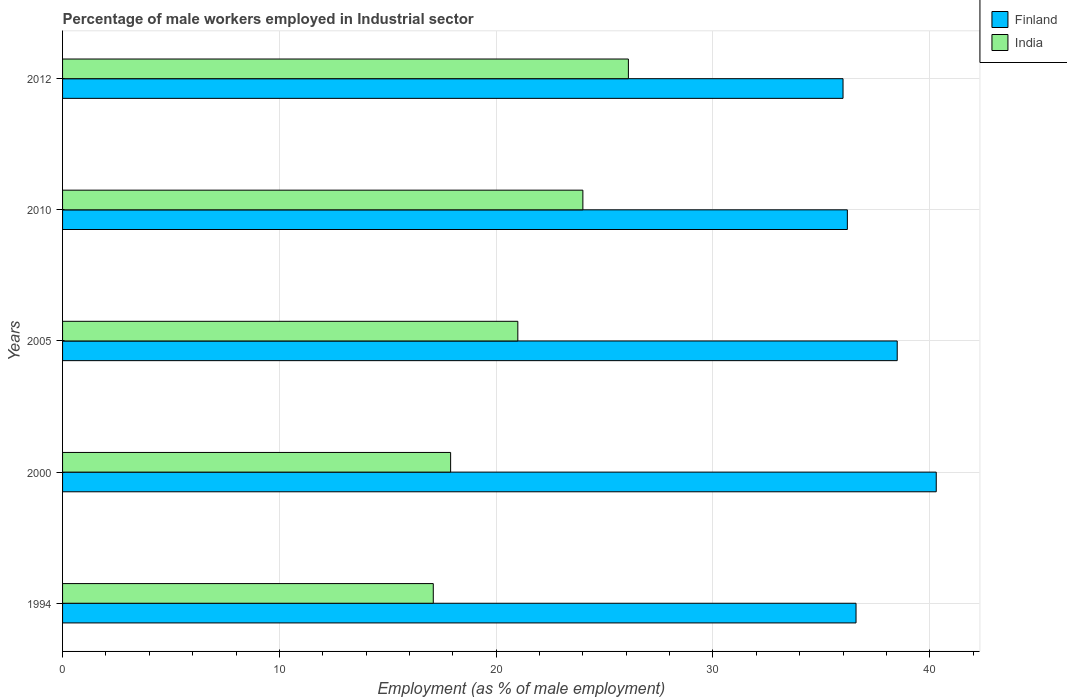How many different coloured bars are there?
Offer a very short reply. 2. How many groups of bars are there?
Offer a terse response. 5. Are the number of bars on each tick of the Y-axis equal?
Your answer should be compact. Yes. How many bars are there on the 4th tick from the top?
Give a very brief answer. 2. What is the label of the 1st group of bars from the top?
Your answer should be compact. 2012. In how many cases, is the number of bars for a given year not equal to the number of legend labels?
Give a very brief answer. 0. What is the percentage of male workers employed in Industrial sector in Finland in 2000?
Give a very brief answer. 40.3. Across all years, what is the maximum percentage of male workers employed in Industrial sector in India?
Make the answer very short. 26.1. Across all years, what is the minimum percentage of male workers employed in Industrial sector in India?
Ensure brevity in your answer.  17.1. In which year was the percentage of male workers employed in Industrial sector in India maximum?
Keep it short and to the point. 2012. What is the total percentage of male workers employed in Industrial sector in Finland in the graph?
Offer a very short reply. 187.6. What is the difference between the percentage of male workers employed in Industrial sector in Finland in 2005 and that in 2010?
Give a very brief answer. 2.3. What is the difference between the percentage of male workers employed in Industrial sector in Finland in 2005 and the percentage of male workers employed in Industrial sector in India in 1994?
Your answer should be compact. 21.4. What is the average percentage of male workers employed in Industrial sector in India per year?
Offer a terse response. 21.22. In the year 1994, what is the difference between the percentage of male workers employed in Industrial sector in Finland and percentage of male workers employed in Industrial sector in India?
Keep it short and to the point. 19.5. What is the ratio of the percentage of male workers employed in Industrial sector in Finland in 1994 to that in 2012?
Keep it short and to the point. 1.02. Is the percentage of male workers employed in Industrial sector in Finland in 2005 less than that in 2010?
Keep it short and to the point. No. Is the difference between the percentage of male workers employed in Industrial sector in Finland in 2005 and 2012 greater than the difference between the percentage of male workers employed in Industrial sector in India in 2005 and 2012?
Your answer should be very brief. Yes. What is the difference between the highest and the second highest percentage of male workers employed in Industrial sector in India?
Keep it short and to the point. 2.1. What is the difference between the highest and the lowest percentage of male workers employed in Industrial sector in Finland?
Provide a succinct answer. 4.3. Is the sum of the percentage of male workers employed in Industrial sector in Finland in 2000 and 2012 greater than the maximum percentage of male workers employed in Industrial sector in India across all years?
Offer a terse response. Yes. What does the 2nd bar from the top in 2000 represents?
Provide a succinct answer. Finland. What does the 1st bar from the bottom in 2000 represents?
Your response must be concise. Finland. Are all the bars in the graph horizontal?
Your answer should be very brief. Yes. What is the difference between two consecutive major ticks on the X-axis?
Your response must be concise. 10. Does the graph contain any zero values?
Ensure brevity in your answer.  No. Does the graph contain grids?
Your response must be concise. Yes. How many legend labels are there?
Ensure brevity in your answer.  2. How are the legend labels stacked?
Give a very brief answer. Vertical. What is the title of the graph?
Your answer should be compact. Percentage of male workers employed in Industrial sector. Does "Iceland" appear as one of the legend labels in the graph?
Your answer should be compact. No. What is the label or title of the X-axis?
Offer a terse response. Employment (as % of male employment). What is the Employment (as % of male employment) in Finland in 1994?
Provide a short and direct response. 36.6. What is the Employment (as % of male employment) of India in 1994?
Provide a short and direct response. 17.1. What is the Employment (as % of male employment) in Finland in 2000?
Ensure brevity in your answer.  40.3. What is the Employment (as % of male employment) in India in 2000?
Provide a succinct answer. 17.9. What is the Employment (as % of male employment) of Finland in 2005?
Offer a terse response. 38.5. What is the Employment (as % of male employment) in Finland in 2010?
Give a very brief answer. 36.2. What is the Employment (as % of male employment) of India in 2010?
Ensure brevity in your answer.  24. What is the Employment (as % of male employment) in Finland in 2012?
Make the answer very short. 36. What is the Employment (as % of male employment) in India in 2012?
Provide a short and direct response. 26.1. Across all years, what is the maximum Employment (as % of male employment) in Finland?
Offer a very short reply. 40.3. Across all years, what is the maximum Employment (as % of male employment) in India?
Ensure brevity in your answer.  26.1. Across all years, what is the minimum Employment (as % of male employment) in Finland?
Give a very brief answer. 36. Across all years, what is the minimum Employment (as % of male employment) of India?
Your answer should be very brief. 17.1. What is the total Employment (as % of male employment) of Finland in the graph?
Your answer should be very brief. 187.6. What is the total Employment (as % of male employment) in India in the graph?
Offer a terse response. 106.1. What is the difference between the Employment (as % of male employment) in Finland in 1994 and that in 2000?
Offer a very short reply. -3.7. What is the difference between the Employment (as % of male employment) in India in 1994 and that in 2000?
Your response must be concise. -0.8. What is the difference between the Employment (as % of male employment) of Finland in 1994 and that in 2005?
Make the answer very short. -1.9. What is the difference between the Employment (as % of male employment) in Finland in 1994 and that in 2010?
Offer a very short reply. 0.4. What is the difference between the Employment (as % of male employment) in India in 1994 and that in 2012?
Your answer should be compact. -9. What is the difference between the Employment (as % of male employment) in Finland in 2000 and that in 2005?
Your answer should be compact. 1.8. What is the difference between the Employment (as % of male employment) in India in 2000 and that in 2005?
Your answer should be very brief. -3.1. What is the difference between the Employment (as % of male employment) in Finland in 2000 and that in 2010?
Keep it short and to the point. 4.1. What is the difference between the Employment (as % of male employment) of India in 2000 and that in 2012?
Give a very brief answer. -8.2. What is the difference between the Employment (as % of male employment) of Finland in 1994 and the Employment (as % of male employment) of India in 2005?
Offer a terse response. 15.6. What is the difference between the Employment (as % of male employment) in Finland in 1994 and the Employment (as % of male employment) in India in 2010?
Make the answer very short. 12.6. What is the difference between the Employment (as % of male employment) in Finland in 1994 and the Employment (as % of male employment) in India in 2012?
Keep it short and to the point. 10.5. What is the difference between the Employment (as % of male employment) in Finland in 2000 and the Employment (as % of male employment) in India in 2005?
Provide a succinct answer. 19.3. What is the difference between the Employment (as % of male employment) of Finland in 2000 and the Employment (as % of male employment) of India in 2010?
Keep it short and to the point. 16.3. What is the difference between the Employment (as % of male employment) of Finland in 2005 and the Employment (as % of male employment) of India in 2010?
Offer a terse response. 14.5. What is the difference between the Employment (as % of male employment) of Finland in 2005 and the Employment (as % of male employment) of India in 2012?
Provide a succinct answer. 12.4. What is the average Employment (as % of male employment) in Finland per year?
Offer a terse response. 37.52. What is the average Employment (as % of male employment) in India per year?
Your answer should be compact. 21.22. In the year 2000, what is the difference between the Employment (as % of male employment) of Finland and Employment (as % of male employment) of India?
Give a very brief answer. 22.4. In the year 2005, what is the difference between the Employment (as % of male employment) of Finland and Employment (as % of male employment) of India?
Offer a terse response. 17.5. In the year 2012, what is the difference between the Employment (as % of male employment) in Finland and Employment (as % of male employment) in India?
Offer a very short reply. 9.9. What is the ratio of the Employment (as % of male employment) in Finland in 1994 to that in 2000?
Your response must be concise. 0.91. What is the ratio of the Employment (as % of male employment) in India in 1994 to that in 2000?
Your answer should be very brief. 0.96. What is the ratio of the Employment (as % of male employment) in Finland in 1994 to that in 2005?
Your answer should be very brief. 0.95. What is the ratio of the Employment (as % of male employment) of India in 1994 to that in 2005?
Offer a terse response. 0.81. What is the ratio of the Employment (as % of male employment) of India in 1994 to that in 2010?
Provide a short and direct response. 0.71. What is the ratio of the Employment (as % of male employment) of Finland in 1994 to that in 2012?
Provide a succinct answer. 1.02. What is the ratio of the Employment (as % of male employment) in India in 1994 to that in 2012?
Provide a short and direct response. 0.66. What is the ratio of the Employment (as % of male employment) of Finland in 2000 to that in 2005?
Keep it short and to the point. 1.05. What is the ratio of the Employment (as % of male employment) in India in 2000 to that in 2005?
Ensure brevity in your answer.  0.85. What is the ratio of the Employment (as % of male employment) of Finland in 2000 to that in 2010?
Offer a terse response. 1.11. What is the ratio of the Employment (as % of male employment) of India in 2000 to that in 2010?
Offer a very short reply. 0.75. What is the ratio of the Employment (as % of male employment) in Finland in 2000 to that in 2012?
Offer a terse response. 1.12. What is the ratio of the Employment (as % of male employment) in India in 2000 to that in 2012?
Keep it short and to the point. 0.69. What is the ratio of the Employment (as % of male employment) in Finland in 2005 to that in 2010?
Keep it short and to the point. 1.06. What is the ratio of the Employment (as % of male employment) of India in 2005 to that in 2010?
Provide a short and direct response. 0.88. What is the ratio of the Employment (as % of male employment) in Finland in 2005 to that in 2012?
Offer a very short reply. 1.07. What is the ratio of the Employment (as % of male employment) of India in 2005 to that in 2012?
Offer a very short reply. 0.8. What is the ratio of the Employment (as % of male employment) of Finland in 2010 to that in 2012?
Your answer should be very brief. 1.01. What is the ratio of the Employment (as % of male employment) in India in 2010 to that in 2012?
Offer a terse response. 0.92. What is the difference between the highest and the second highest Employment (as % of male employment) of Finland?
Ensure brevity in your answer.  1.8. What is the difference between the highest and the second highest Employment (as % of male employment) in India?
Offer a very short reply. 2.1. What is the difference between the highest and the lowest Employment (as % of male employment) of India?
Keep it short and to the point. 9. 